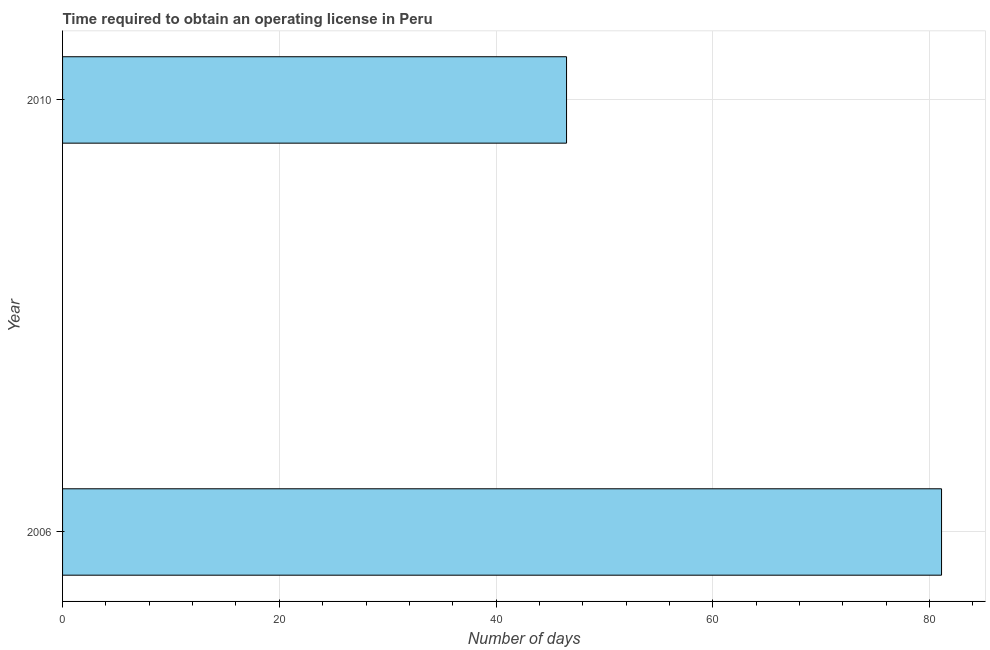Does the graph contain any zero values?
Provide a succinct answer. No. Does the graph contain grids?
Your response must be concise. Yes. What is the title of the graph?
Your answer should be compact. Time required to obtain an operating license in Peru. What is the label or title of the X-axis?
Keep it short and to the point. Number of days. What is the number of days to obtain operating license in 2006?
Provide a succinct answer. 81.1. Across all years, what is the maximum number of days to obtain operating license?
Offer a very short reply. 81.1. Across all years, what is the minimum number of days to obtain operating license?
Provide a short and direct response. 46.5. In which year was the number of days to obtain operating license maximum?
Offer a very short reply. 2006. What is the sum of the number of days to obtain operating license?
Provide a short and direct response. 127.6. What is the difference between the number of days to obtain operating license in 2006 and 2010?
Your response must be concise. 34.6. What is the average number of days to obtain operating license per year?
Your answer should be compact. 63.8. What is the median number of days to obtain operating license?
Offer a terse response. 63.8. In how many years, is the number of days to obtain operating license greater than 44 days?
Provide a short and direct response. 2. What is the ratio of the number of days to obtain operating license in 2006 to that in 2010?
Make the answer very short. 1.74. How many bars are there?
Offer a very short reply. 2. How many years are there in the graph?
Your response must be concise. 2. Are the values on the major ticks of X-axis written in scientific E-notation?
Ensure brevity in your answer.  No. What is the Number of days of 2006?
Ensure brevity in your answer.  81.1. What is the Number of days in 2010?
Your answer should be very brief. 46.5. What is the difference between the Number of days in 2006 and 2010?
Provide a short and direct response. 34.6. What is the ratio of the Number of days in 2006 to that in 2010?
Your answer should be very brief. 1.74. 